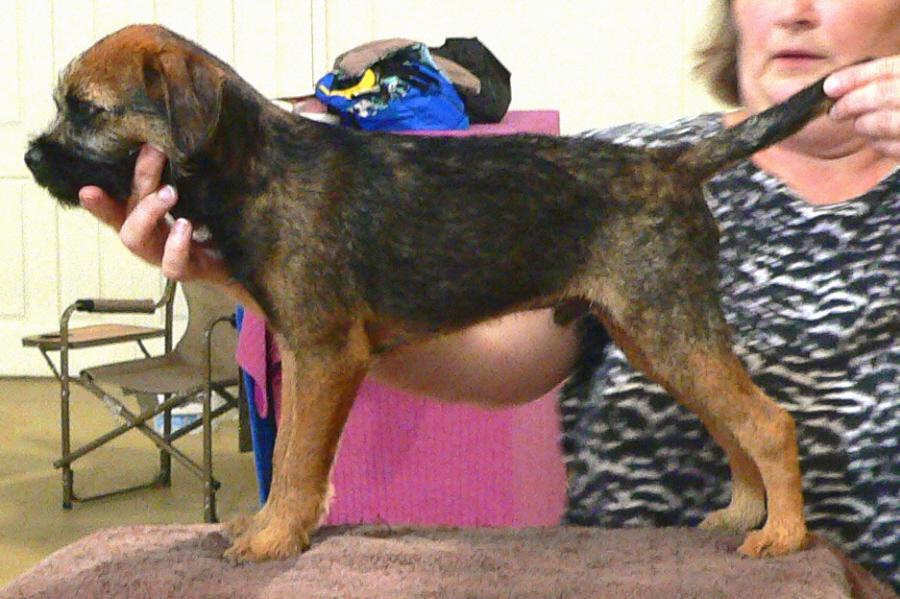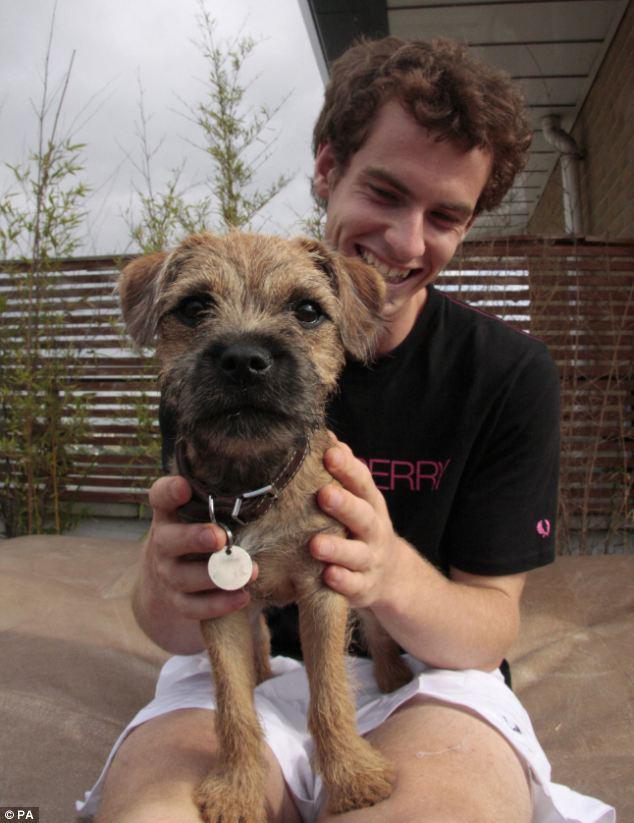The first image is the image on the left, the second image is the image on the right. Given the left and right images, does the statement "Each image shows one person with exactly one dog, and one image shows a person propping the dog's chin with one hand." hold true? Answer yes or no. Yes. The first image is the image on the left, the second image is the image on the right. Examine the images to the left and right. Is the description "There are at most two dogs." accurate? Answer yes or no. Yes. 